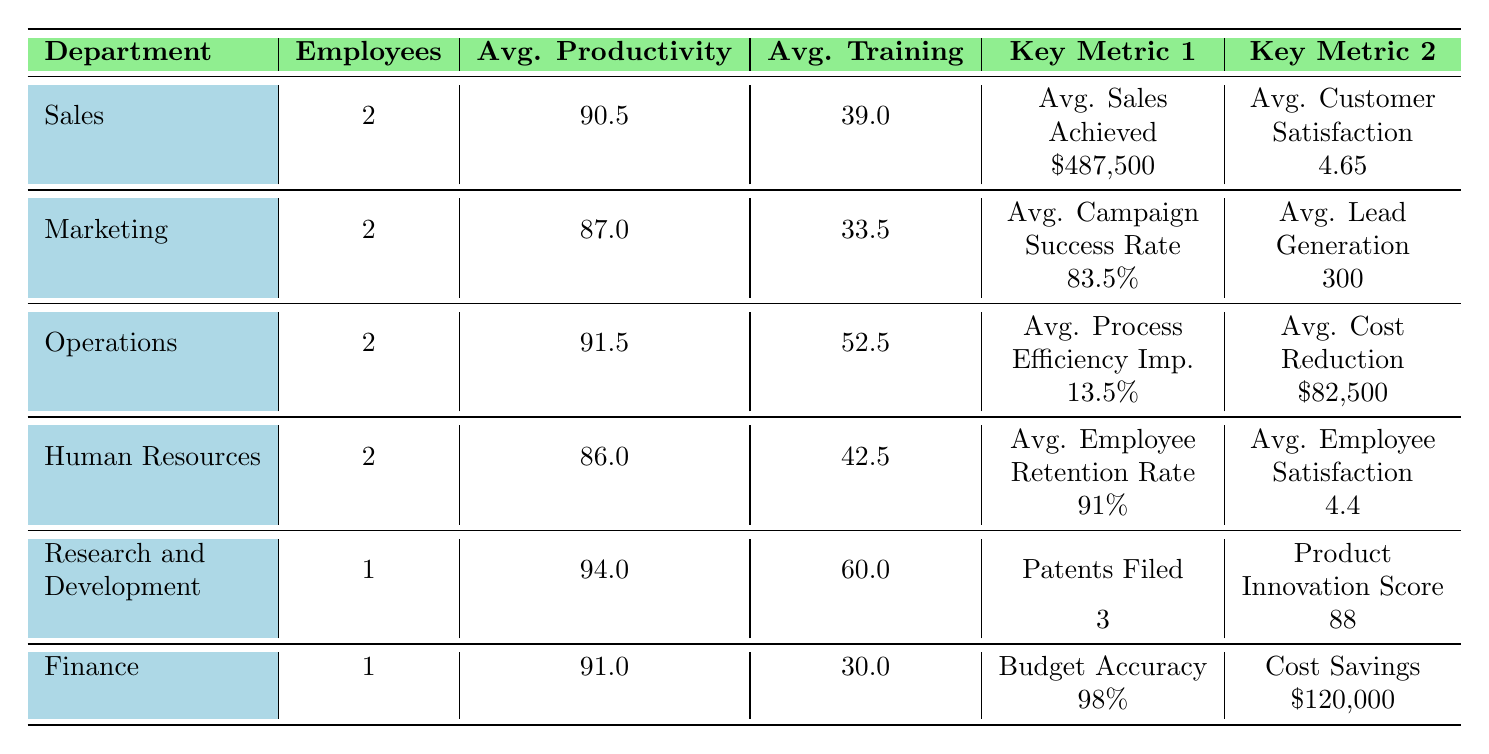What is the average productivity score for the Sales department? The Sales department has two employees with productivity scores of 90.5 and 89. To find the average, we add these two scores (90.5 + 89 = 179.5) and divide by the number of employees (2), which gives us 179.5 / 2 = 89.75.
Answer: 89.75 What is the highest customer satisfaction score among employees? The table lists sales professionals with customer satisfaction scores of 4.7 and 4.6. The highest value is 4.7 obtained by John Smith in the Sales department.
Answer: 4.7 Is the average training hours in the Marketing department greater than that in Human Resources? The average training hours for the Marketing department are calculated as (35 + 32) / 2 = 33.5, and for Human Resources, the training hours average as (45 + 40) / 2 = 42.5. Since 33.5 < 42.5, the statement is false.
Answer: No What is the total number of patents filed across all departments? The only department reporting patents filed is Research and Development, with a total of 3 patents. No other departments report this metric, so the total is simply 3.
Answer: 3 Which department has the highest average cost savings? The Finance department reports a cost savings of 120,000, which is higher than the Operations department, which shows average cost reduction of 82,500. There are no other departments reporting cost savings, so Finance has the highest average.
Answer: Finance What is the average employee retention rate for the Human Resources department? The Human Resources department has two employees showing employee retention rates of 92% and 90%. To find the average, we add 92 + 90 = 182 and divide by 2. The average retention rate is therefore 182 / 2 = 91%.
Answer: 91% Which department achieved the highest average sales? The Sales department has employee sales achieved values of 550,000 and 425,000. Calculating the average: (550000 + 425000) / 2 = 487500. No other department reports sales metrics, making Sales the highest.
Answer: Sales What is the average campaign success rate in Marketing? In the Marketing department, the campaign success rates of Emma Johnson and Laura Garcia are 85% and 82%, respectively. Thus, the average is calculated as (85 + 82) / 2 = 83.5%.
Answer: 83.5% Which two departments have the highest training hours on average? The Research and Development department has an average of 60 hours, and the Operations department averages 52.5 hours. Comparing these with other departments, R&D has the highest average and Operations is the second highest.
Answer: Research and Development and Operations 